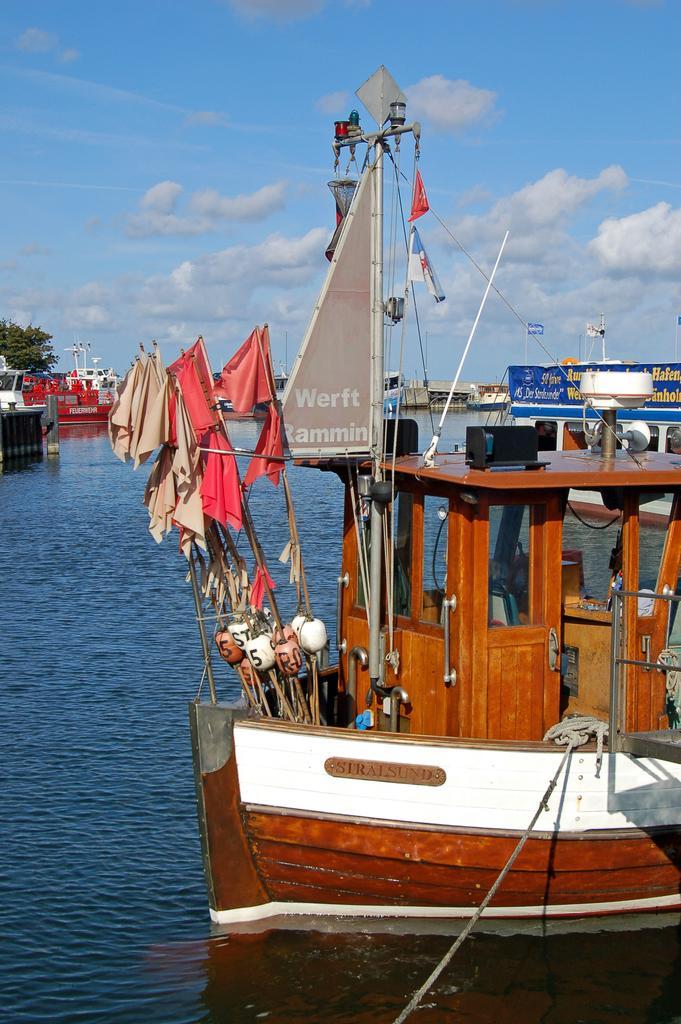In one or two sentences, can you explain what this image depicts? In this picture we can see boats on the water, flags, rope, board, trees and some objects and in the background we can see the sky with clouds. 